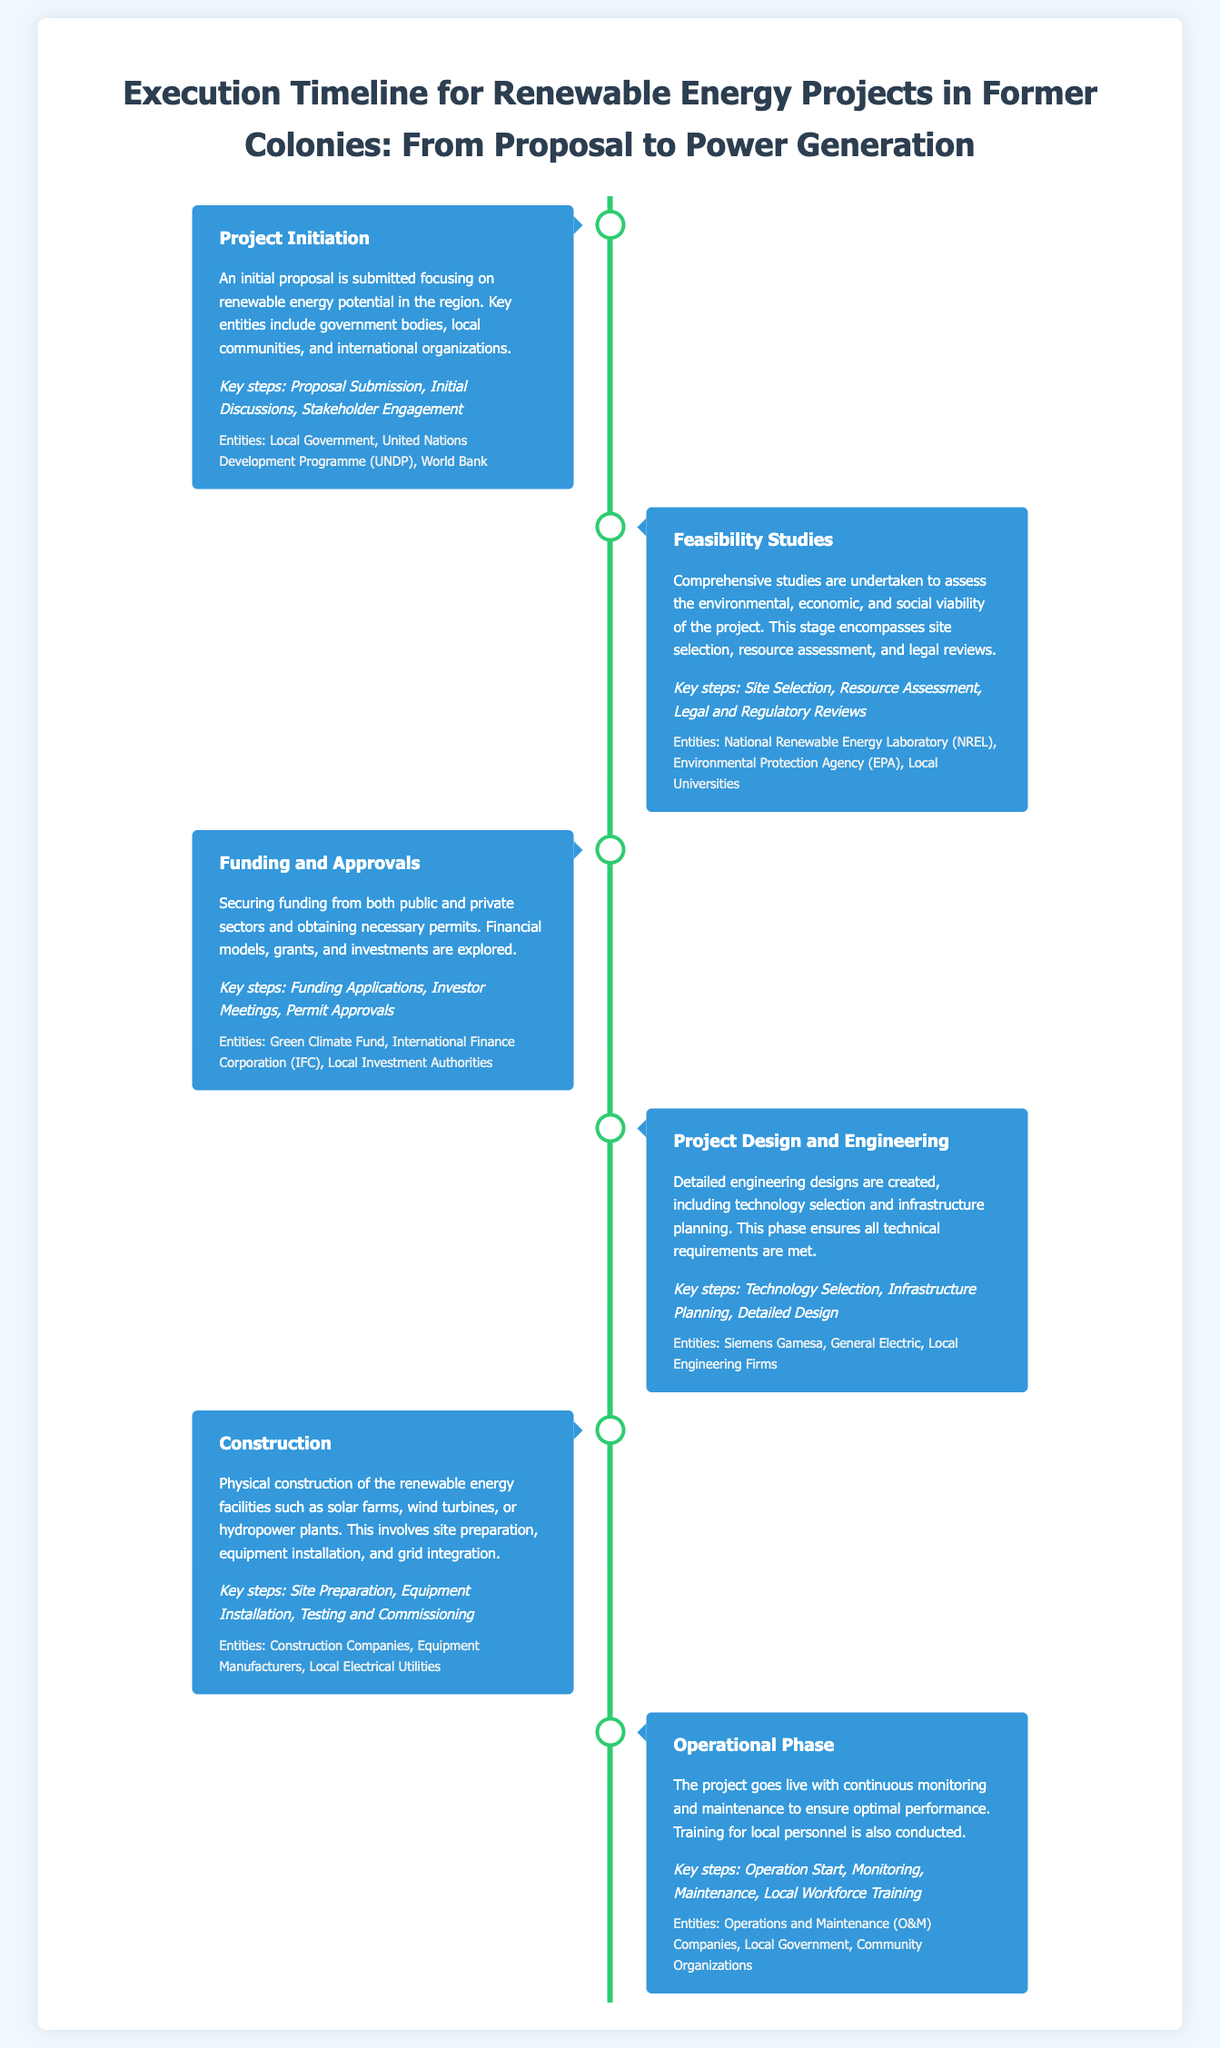What is the first stage of the project timeline? The first stage involves submitting an initial proposal focusing on renewable energy potential.
Answer: Project Initiation Which entities are involved in the funding and approvals stage? This stage involves securing funding from public and private sectors and includes key entities.
Answer: Green Climate Fund, International Finance Corporation, Local Investment Authorities What key step involves selecting technology for the project? This key step is part of the Project Design and Engineering stage.
Answer: Technology Selection What is the duration of the operational phase? The timeline is not specified in the document, but involves continuous monitoring and maintenance.
Answer: Continuous Which entity is mentioned in the construction stage? This stage involves physical construction and includes multiple key entities.
Answer: Construction Companies What are the key steps involved in the feasibility studies? This stage assesses various factors to determine the project’s viability.
Answer: Site Selection, Resource Assessment, Legal and Regulatory Reviews How many stages are outlined in the document? The document lists distinct phases of project execution leading to power generation.
Answer: Six Which stage comes after the funding and approvals? This stage follows after securing funding and prior to construction.
Answer: Project Design and Engineering 